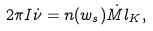Convert formula to latex. <formula><loc_0><loc_0><loc_500><loc_500>2 \pi I \dot { \nu } = n ( w _ { s } ) \dot { M } l _ { K } ,</formula> 